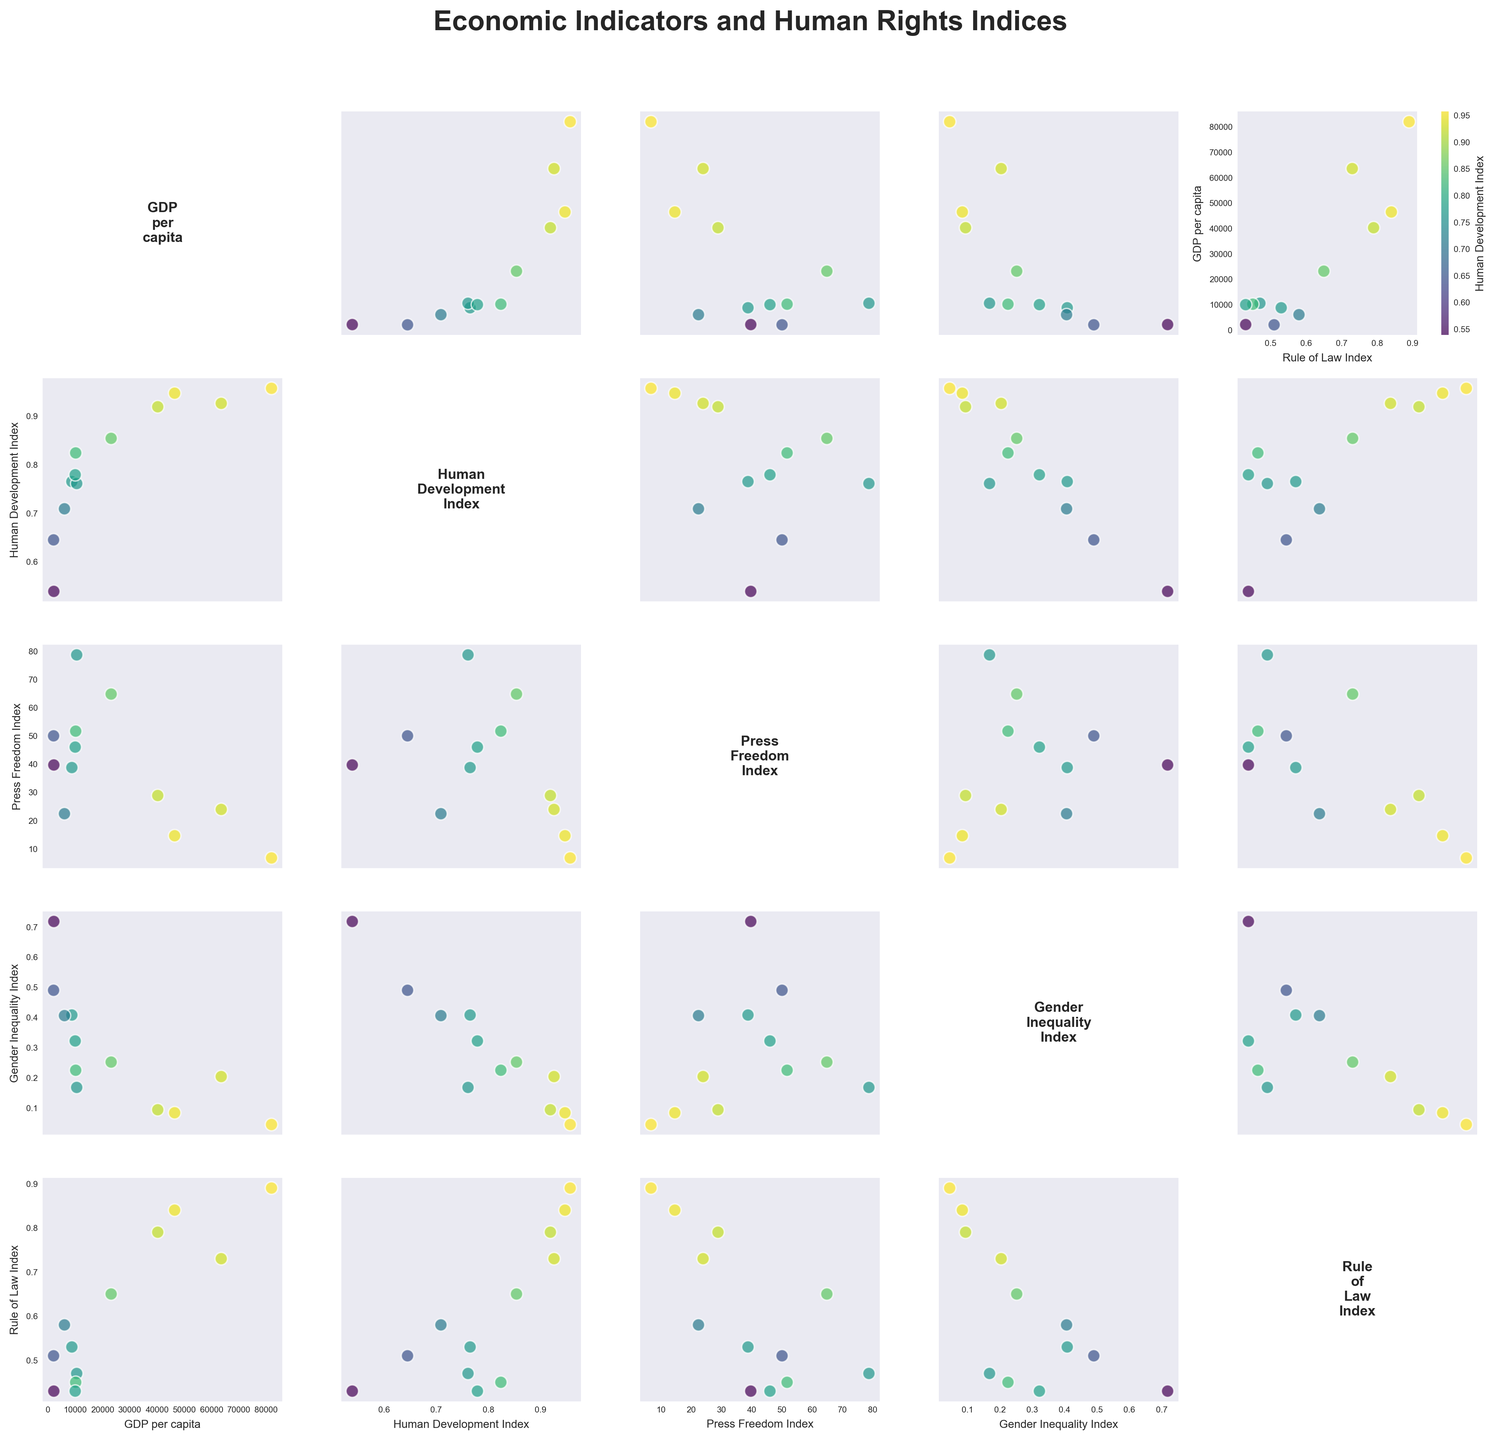what is the title of the figure? The figure includes a title at the top that describes the overall content of the plot. You can directly read the title from this location.
Answer: Economic Indicators and Human Rights Indices How many countries are represented in the scatterplot matrix? The number of data points in a scatterplot corresponds to the number of countries represented. Each data point represents a country from the provided dataset.
Answer: 12 Which countries have the highest and lowest GDP per capita? By examining the scatterplot for GDP per capita against Human Development Index or another variable, you can identify the data points at the uppermost and lowermost positions along the GDP per capita axis.
Answer: Norway (highest), Nigeria (lowest) Is there a visible trend between Human Development Index and GDP per capita? By looking at the scatterplot of Human Development Index (HDI) and GDP per capita, one can observe whether the points show a positive, negative, or no trend. Positions and slanted alignments of points can suggest such a trend.
Answer: Positive trend Which country has a low Gender Inequality Index and high Rule of Law Index? In the scatterplot comparing Gender Inequality Index and Rule of Law Index, identify the data point positioned low on the Gender Inequality Index axis and high on the Rule of Law Index axis. Cross-referencing with the provided dataset will specify the country.
Answer: Norway Is there a noticeable correlation between Press Freedom Index and GDP per capita? By examining the scatter matrix where Press Freedom Index is plotted against GDP per capita, one can see if the points are closely aligned along a line which indicates a correlation.
Answer: Generally, no clear correlation Which two variables have the clearest inverse relationship? In a scatterplot matrix, an inverse relationship is indicated by data points trending downwards from left to right. Evaluate all pairings of variables to identify which set most clearly shows such a trend.
Answer: GDP per capita and Gender Inequality Index For countries with high Human Development Index, what can you infer about their Rule of Law Index? Observe scatterplots where Human Development Index is plotted against Rule of Law Index. Identify if countries with higher HDI are clustered at higher values of Rule of Law Index indicating a correlation.
Answer: Higher Rule of Law Index What is the range of the Human Development Index across the countries? The range is calculated by identifying the highest and lowest values of the Human Development Index in the scatter plots or by directly reading those values from the dataset.
Answer: 0.957 - 0.539 